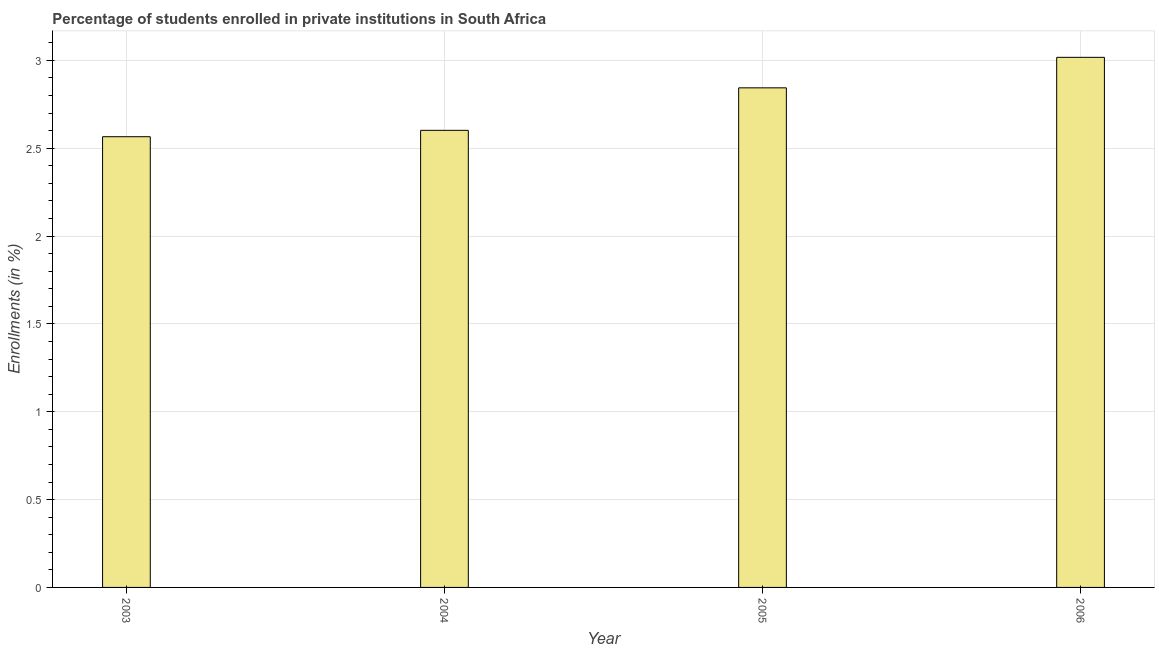What is the title of the graph?
Your answer should be compact. Percentage of students enrolled in private institutions in South Africa. What is the label or title of the Y-axis?
Keep it short and to the point. Enrollments (in %). What is the enrollments in private institutions in 2005?
Your response must be concise. 2.84. Across all years, what is the maximum enrollments in private institutions?
Your response must be concise. 3.02. Across all years, what is the minimum enrollments in private institutions?
Provide a succinct answer. 2.57. In which year was the enrollments in private institutions maximum?
Your answer should be compact. 2006. In which year was the enrollments in private institutions minimum?
Offer a terse response. 2003. What is the sum of the enrollments in private institutions?
Give a very brief answer. 11.03. What is the difference between the enrollments in private institutions in 2005 and 2006?
Give a very brief answer. -0.17. What is the average enrollments in private institutions per year?
Your answer should be very brief. 2.76. What is the median enrollments in private institutions?
Your response must be concise. 2.72. In how many years, is the enrollments in private institutions greater than 1.2 %?
Your answer should be compact. 4. What is the ratio of the enrollments in private institutions in 2004 to that in 2006?
Ensure brevity in your answer.  0.86. Is the enrollments in private institutions in 2005 less than that in 2006?
Your response must be concise. Yes. Is the difference between the enrollments in private institutions in 2004 and 2006 greater than the difference between any two years?
Ensure brevity in your answer.  No. What is the difference between the highest and the second highest enrollments in private institutions?
Your answer should be compact. 0.17. Is the sum of the enrollments in private institutions in 2005 and 2006 greater than the maximum enrollments in private institutions across all years?
Ensure brevity in your answer.  Yes. What is the difference between the highest and the lowest enrollments in private institutions?
Offer a terse response. 0.45. How many bars are there?
Provide a short and direct response. 4. Are all the bars in the graph horizontal?
Your response must be concise. No. How many years are there in the graph?
Keep it short and to the point. 4. What is the difference between two consecutive major ticks on the Y-axis?
Offer a very short reply. 0.5. What is the Enrollments (in %) in 2003?
Provide a short and direct response. 2.57. What is the Enrollments (in %) in 2004?
Give a very brief answer. 2.6. What is the Enrollments (in %) in 2005?
Your response must be concise. 2.84. What is the Enrollments (in %) of 2006?
Keep it short and to the point. 3.02. What is the difference between the Enrollments (in %) in 2003 and 2004?
Your answer should be very brief. -0.04. What is the difference between the Enrollments (in %) in 2003 and 2005?
Your answer should be very brief. -0.28. What is the difference between the Enrollments (in %) in 2003 and 2006?
Provide a succinct answer. -0.45. What is the difference between the Enrollments (in %) in 2004 and 2005?
Provide a succinct answer. -0.24. What is the difference between the Enrollments (in %) in 2004 and 2006?
Keep it short and to the point. -0.42. What is the difference between the Enrollments (in %) in 2005 and 2006?
Offer a terse response. -0.17. What is the ratio of the Enrollments (in %) in 2003 to that in 2004?
Your answer should be very brief. 0.99. What is the ratio of the Enrollments (in %) in 2003 to that in 2005?
Your answer should be compact. 0.9. What is the ratio of the Enrollments (in %) in 2004 to that in 2005?
Offer a very short reply. 0.92. What is the ratio of the Enrollments (in %) in 2004 to that in 2006?
Your response must be concise. 0.86. What is the ratio of the Enrollments (in %) in 2005 to that in 2006?
Give a very brief answer. 0.94. 